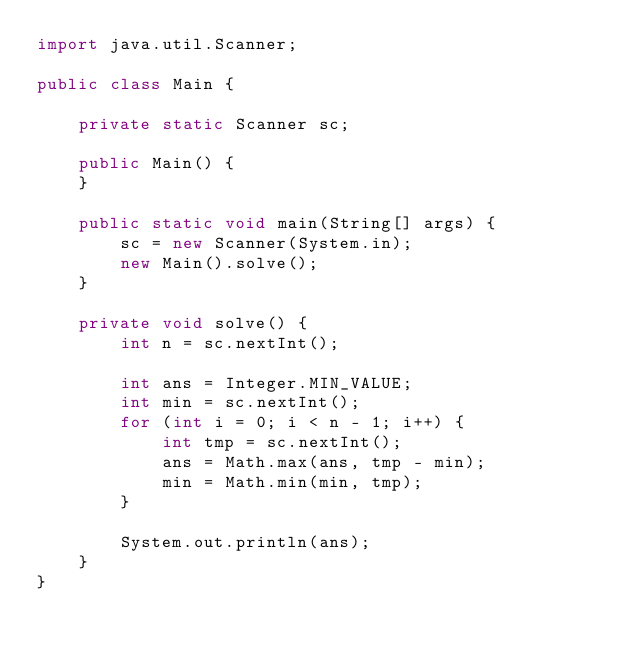<code> <loc_0><loc_0><loc_500><loc_500><_Java_>import java.util.Scanner;

public class Main {

    private static Scanner sc;

    public Main() {
    }

    public static void main(String[] args) {
        sc = new Scanner(System.in);
        new Main().solve();
    }

    private void solve() {
        int n = sc.nextInt();

        int ans = Integer.MIN_VALUE;
        int min = sc.nextInt();
        for (int i = 0; i < n - 1; i++) {
            int tmp = sc.nextInt();
            ans = Math.max(ans, tmp - min);
            min = Math.min(min, tmp);
        }

        System.out.println(ans);
    }
}</code> 